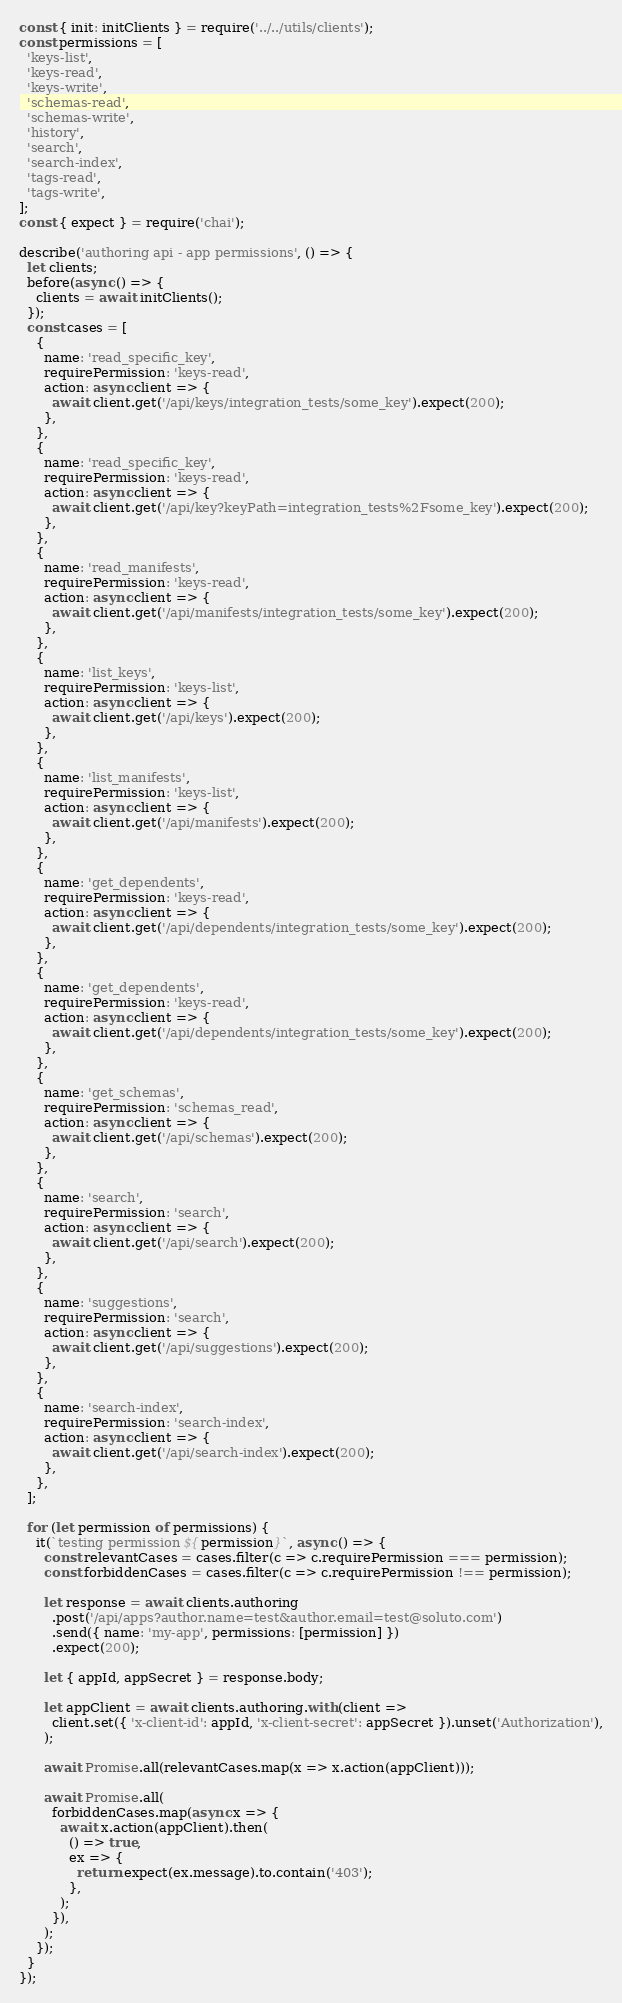Convert code to text. <code><loc_0><loc_0><loc_500><loc_500><_JavaScript_>const { init: initClients } = require('../../utils/clients');
const permissions = [
  'keys-list',
  'keys-read',
  'keys-write',
  'schemas-read',
  'schemas-write',
  'history',
  'search',
  'search-index',
  'tags-read',
  'tags-write',
];
const { expect } = require('chai');

describe('authoring api - app permissions', () => {
  let clients;
  before(async () => {
    clients = await initClients();
  });
  const cases = [
    {
      name: 'read_specific_key',
      requirePermission: 'keys-read',
      action: async client => {
        await client.get('/api/keys/integration_tests/some_key').expect(200);
      },
    },
    {
      name: 'read_specific_key',
      requirePermission: 'keys-read',
      action: async client => {
        await client.get('/api/key?keyPath=integration_tests%2Fsome_key').expect(200);
      },
    },
    {
      name: 'read_manifests',
      requirePermission: 'keys-read',
      action: async client => {
        await client.get('/api/manifests/integration_tests/some_key').expect(200);
      },
    },
    {
      name: 'list_keys',
      requirePermission: 'keys-list',
      action: async client => {
        await client.get('/api/keys').expect(200);
      },
    },
    {
      name: 'list_manifests',
      requirePermission: 'keys-list',
      action: async client => {
        await client.get('/api/manifests').expect(200);
      },
    },
    {
      name: 'get_dependents',
      requirePermission: 'keys-read',
      action: async client => {
        await client.get('/api/dependents/integration_tests/some_key').expect(200);
      },
    },
    {
      name: 'get_dependents',
      requirePermission: 'keys-read',
      action: async client => {
        await client.get('/api/dependents/integration_tests/some_key').expect(200);
      },
    },
    {
      name: 'get_schemas',
      requirePermission: 'schemas_read',
      action: async client => {
        await client.get('/api/schemas').expect(200);
      },
    },
    {
      name: 'search',
      requirePermission: 'search',
      action: async client => {
        await client.get('/api/search').expect(200);
      },
    },
    {
      name: 'suggestions',
      requirePermission: 'search',
      action: async client => {
        await client.get('/api/suggestions').expect(200);
      },
    },
    {
      name: 'search-index',
      requirePermission: 'search-index',
      action: async client => {
        await client.get('/api/search-index').expect(200);
      },
    },
  ];

  for (let permission of permissions) {
    it(`testing permission ${permission}`, async () => {
      const relevantCases = cases.filter(c => c.requirePermission === permission);
      const forbiddenCases = cases.filter(c => c.requirePermission !== permission);

      let response = await clients.authoring
        .post('/api/apps?author.name=test&author.email=test@soluto.com')
        .send({ name: 'my-app', permissions: [permission] })
        .expect(200);

      let { appId, appSecret } = response.body;

      let appClient = await clients.authoring.with(client =>
        client.set({ 'x-client-id': appId, 'x-client-secret': appSecret }).unset('Authorization'),
      );

      await Promise.all(relevantCases.map(x => x.action(appClient)));

      await Promise.all(
        forbiddenCases.map(async x => {
          await x.action(appClient).then(
            () => true,
            ex => {
              return expect(ex.message).to.contain('403');
            },
          );
        }),
      );
    });
  }
});
</code> 